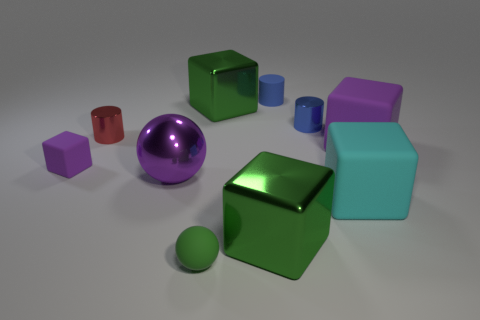Subtract all cyan rubber blocks. How many blocks are left? 4 Subtract all green cubes. How many cubes are left? 3 Subtract all cylinders. How many objects are left? 7 Subtract 1 cylinders. How many cylinders are left? 2 Add 7 big green metal cubes. How many big green metal cubes exist? 9 Subtract 1 cyan cubes. How many objects are left? 9 Subtract all red balls. Subtract all red blocks. How many balls are left? 2 Subtract all brown cylinders. How many cyan blocks are left? 1 Subtract all tiny purple cubes. Subtract all large purple metal objects. How many objects are left? 8 Add 8 tiny red things. How many tiny red things are left? 9 